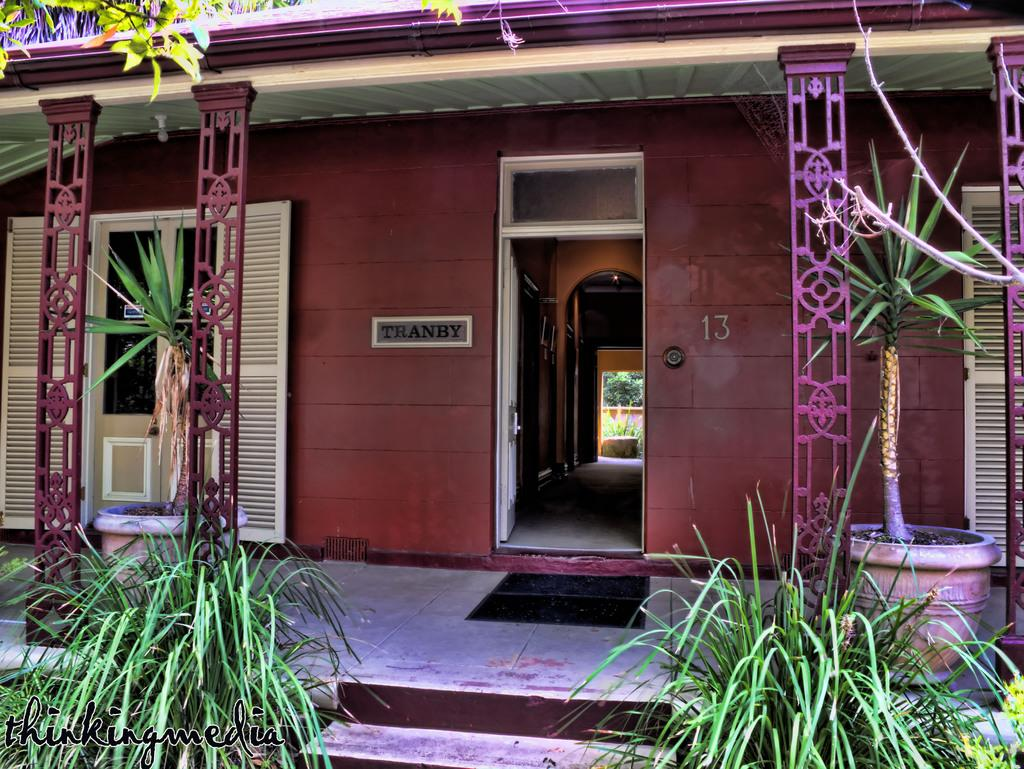What type of structure is present in the image? There is a house in the image. What is located near the house? There is a board near the house. Are there any decorative elements in front of the house? Yes, there are two flower pots in front of the house. What type of vegetation can be seen in the image? There is grass visible in the image. What other natural element is present in the image? There is a tree in the image. What type of fruit is hanging from the tree in the image? There is no fruit visible on the tree in the image. Where can the students have their lunch in the image? There is no lunchroom or indication of students in the image. 